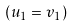<formula> <loc_0><loc_0><loc_500><loc_500>( u _ { 1 } = v _ { 1 } )</formula> 